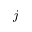Convert formula to latex. <formula><loc_0><loc_0><loc_500><loc_500>j</formula> 